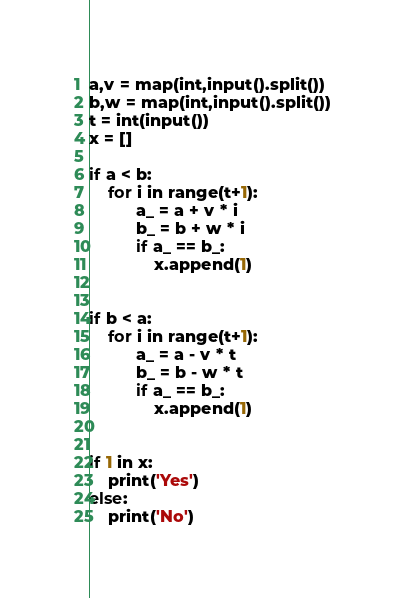<code> <loc_0><loc_0><loc_500><loc_500><_Python_>a,v = map(int,input().split())
b,w = map(int,input().split())
t = int(input())
x = []
 
if a < b:
    for i in range(t+1):
          a_ = a + v * i
          b_ = b + w * i
          if a_ == b_:
              x.append(1)

 
if b < a:
    for i in range(t+1):
          a_ = a - v * t
          b_ = b - w * t
          if a_ == b_:
              x.append(1)

 
if 1 in x:
    print('Yes')
else:
    print('No')</code> 